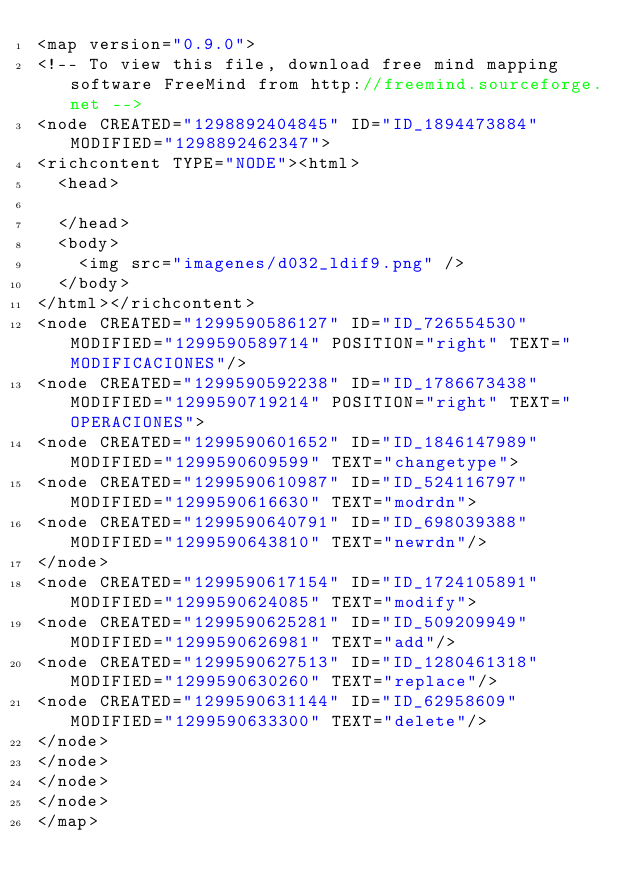<code> <loc_0><loc_0><loc_500><loc_500><_ObjectiveC_><map version="0.9.0">
<!-- To view this file, download free mind mapping software FreeMind from http://freemind.sourceforge.net -->
<node CREATED="1298892404845" ID="ID_1894473884" MODIFIED="1298892462347">
<richcontent TYPE="NODE"><html>
  <head>
    
  </head>
  <body>
    <img src="imagenes/d032_ldif9.png" />
  </body>
</html></richcontent>
<node CREATED="1299590586127" ID="ID_726554530" MODIFIED="1299590589714" POSITION="right" TEXT="MODIFICACIONES"/>
<node CREATED="1299590592238" ID="ID_1786673438" MODIFIED="1299590719214" POSITION="right" TEXT="OPERACIONES">
<node CREATED="1299590601652" ID="ID_1846147989" MODIFIED="1299590609599" TEXT="changetype">
<node CREATED="1299590610987" ID="ID_524116797" MODIFIED="1299590616630" TEXT="modrdn">
<node CREATED="1299590640791" ID="ID_698039388" MODIFIED="1299590643810" TEXT="newrdn"/>
</node>
<node CREATED="1299590617154" ID="ID_1724105891" MODIFIED="1299590624085" TEXT="modify">
<node CREATED="1299590625281" ID="ID_509209949" MODIFIED="1299590626981" TEXT="add"/>
<node CREATED="1299590627513" ID="ID_1280461318" MODIFIED="1299590630260" TEXT="replace"/>
<node CREATED="1299590631144" ID="ID_62958609" MODIFIED="1299590633300" TEXT="delete"/>
</node>
</node>
</node>
</node>
</map>
</code> 